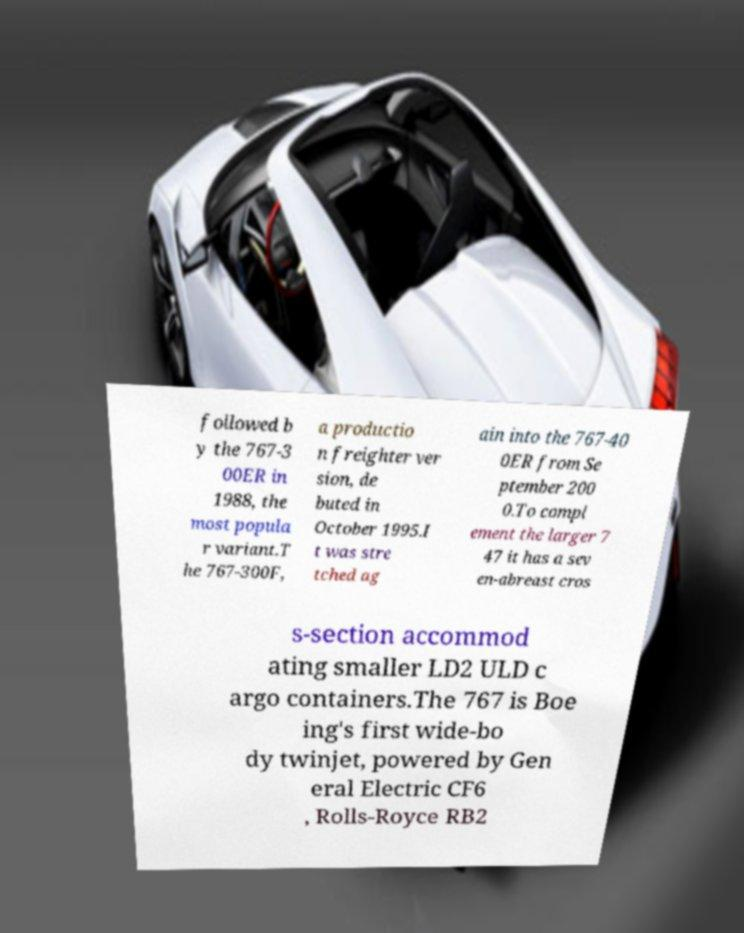Can you accurately transcribe the text from the provided image for me? followed b y the 767-3 00ER in 1988, the most popula r variant.T he 767-300F, a productio n freighter ver sion, de buted in October 1995.I t was stre tched ag ain into the 767-40 0ER from Se ptember 200 0.To compl ement the larger 7 47 it has a sev en-abreast cros s-section accommod ating smaller LD2 ULD c argo containers.The 767 is Boe ing's first wide-bo dy twinjet, powered by Gen eral Electric CF6 , Rolls-Royce RB2 